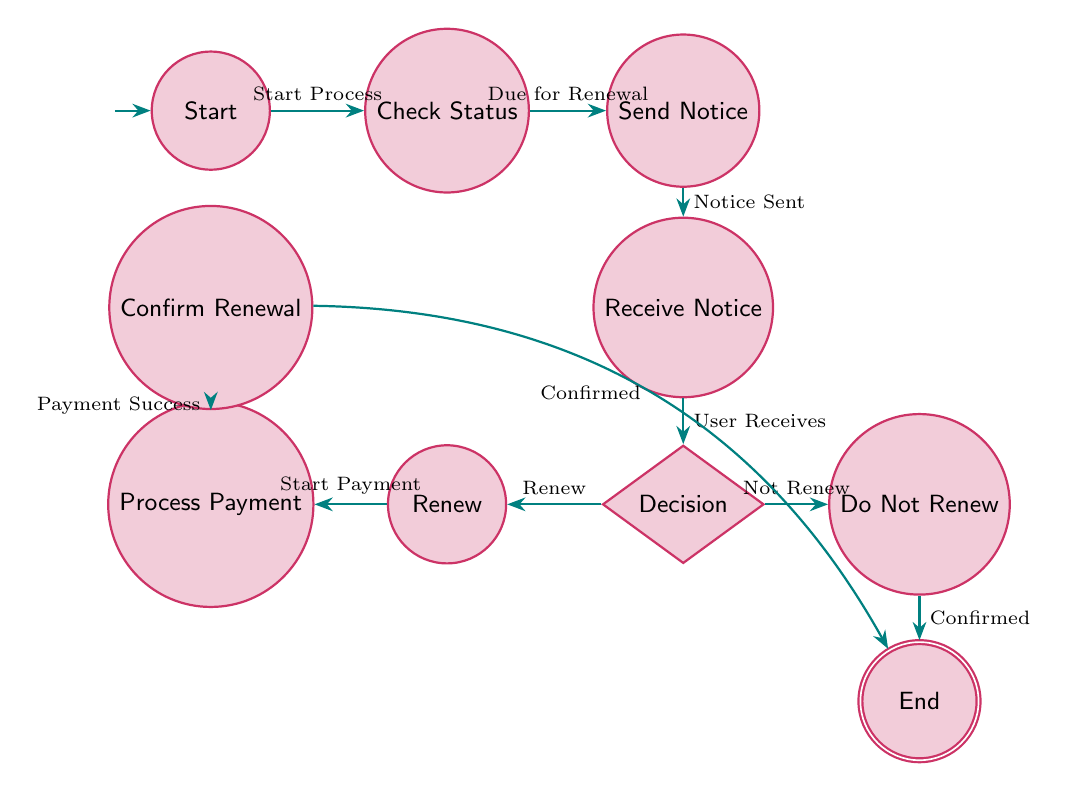What is the initial state of the diagram? The initial state is indicated by the arrow pointing to it, marking the starting point of the process. In this diagram, the initial state is labeled as "Start."
Answer: Start How many total states are present in the diagram? By counting all the states listed in the data, including the initial and end states, we determine the total number of states. There are ten states in total.
Answer: 10 What is the transition trigger from "Check Membership Status" to "Send Renewal Notice"? The transition from "Check Membership Status" to "Send Renewal Notice" occurs based on the trigger condition defined in the transitions. This trigger is labeled "Membership Due for Renewal."
Answer: Membership Due for Renewal What state does the user reach after receiving the renewal notice? After the user receives the renewal notice, they proceed to a decision-making state. The flow from "Receive Renewal Notice" leads directly to the "Decision Point" state.
Answer: Decision Point If a user decides not to renew, what is the next state? When a user decides not to renew their membership, the diagram specifies a direct transition to the "Do Not Renew" state, which then flows to the final "End" state.
Answer: End What happens after the "Process Renewal Payment" state? Following the "Process Renewal Payment" state, the next step in the diagram is to confirm the renewal. This is indicated by the transition to the "Confirm Renewal" state.
Answer: Confirm Renewal In the diagram, what action leads the user from "Decision Point" to "Renew Membership"? The transition occurs when the user decides to renew their membership, which is explicitly marked as a trigger for this path.
Answer: User Decides to Renew Which state signifies the completion of the renewal process? The "End" state is designated as the final state that indicates the successful completion of the membership renewal process.
Answer: End How many transitions are illustrated in the diagram? Count the arrows representing transitions in the diagram; each arrow corresponds to a distinct transition between states. There are nine transitions displayed.
Answer: 9 What triggers the transition to "Confirm Renewal"? The transition to "Confirm Renewal" occurs once the payment process is finished successfully, as indicated by the trigger "Payment Successful."
Answer: Payment Successful 